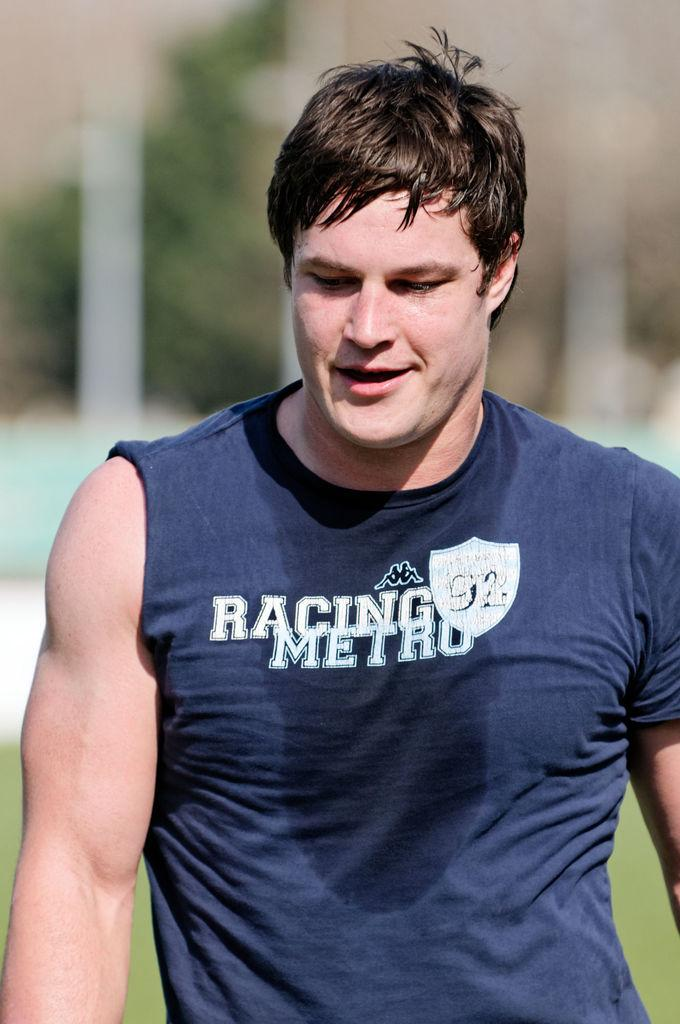Provide a one-sentence caption for the provided image. sweaty man in blue shirt that has racing metro written on it. 